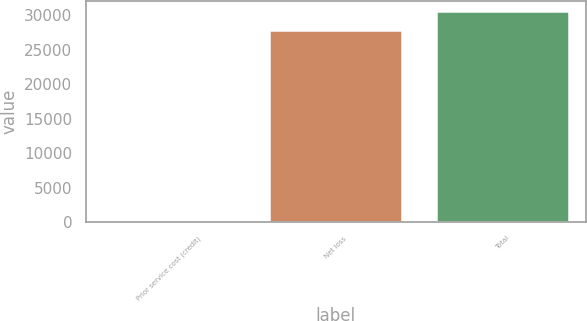Convert chart. <chart><loc_0><loc_0><loc_500><loc_500><bar_chart><fcel>Prior service cost (credit)<fcel>Net loss<fcel>Total<nl><fcel>86<fcel>27789<fcel>30567.9<nl></chart> 